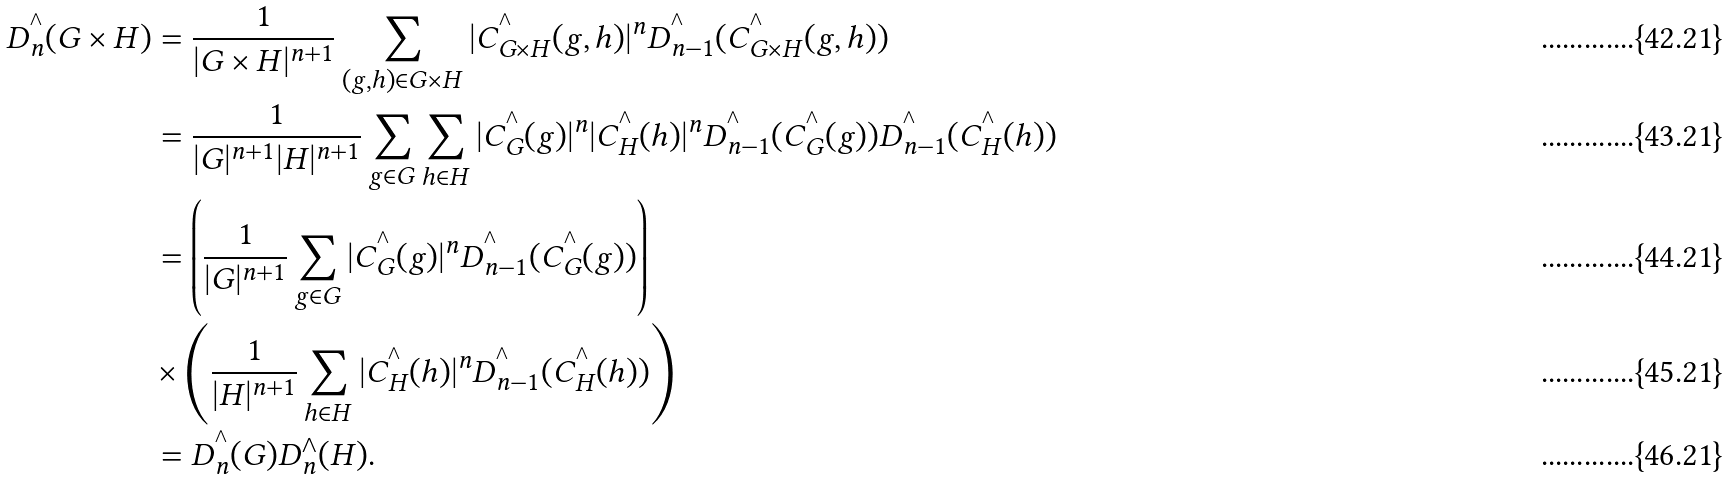Convert formula to latex. <formula><loc_0><loc_0><loc_500><loc_500>D ^ { ^ { \wedge } } _ { n } ( G \times H ) & = \frac { 1 } { | G \times H | ^ { n + 1 } } \sum _ { ( g , h ) \in G \times H } | C ^ { ^ { \wedge } } _ { G \times H } ( g , h ) | ^ { n } D ^ { ^ { \wedge } } _ { n - 1 } ( C ^ { ^ { \wedge } } _ { G \times H } ( g , h ) ) \\ & = \frac { 1 } { | G | ^ { n + 1 } | H | ^ { n + 1 } } \sum _ { g \in G } \sum _ { h \in H } | C ^ { ^ { \wedge } } _ { G } ( g ) | ^ { n } | C ^ { ^ { \wedge } } _ { H } ( h ) | ^ { n } D ^ { ^ { \wedge } } _ { n - 1 } ( C ^ { ^ { \wedge } } _ { G } ( g ) ) D ^ { ^ { \wedge } } _ { n - 1 } ( C ^ { ^ { \wedge } } _ { H } ( h ) ) \\ & = \left ( \frac { 1 } { | G | ^ { n + 1 } } \sum _ { g \in G } | C ^ { ^ { \wedge } } _ { G } ( g ) | ^ { n } D ^ { ^ { \wedge } } _ { n - 1 } ( C ^ { ^ { \wedge } } _ { G } ( g ) ) \right ) \\ & \times \left ( \frac { 1 } { | H | ^ { n + 1 } } \sum _ { h \in H } | C ^ { ^ { \wedge } } _ { H } ( h ) | ^ { n } D ^ { ^ { \wedge } } _ { n - 1 } ( C ^ { ^ { \wedge } } _ { H } ( h ) ) \right ) \\ & = D ^ { ^ { \wedge } } _ { n } ( G ) D ^ { \wedge } _ { n } ( H ) .</formula> 